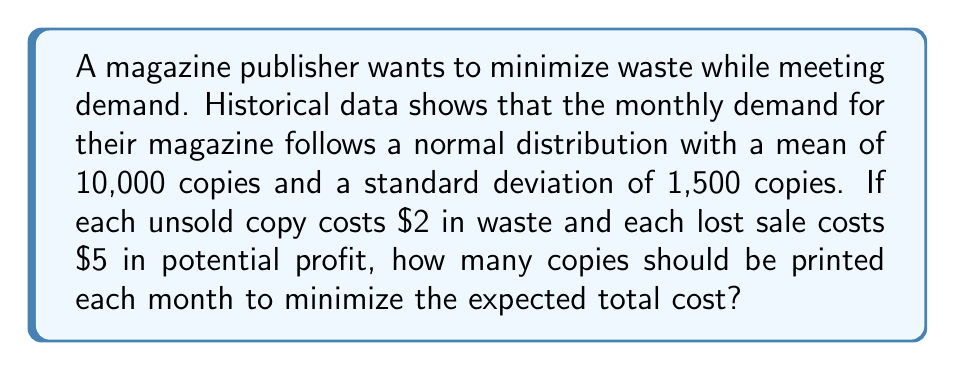Give your solution to this math problem. To solve this problem, we need to use the concept of the newsvendor model from inventory management theory. The optimal number of copies to print is the one that balances the cost of overprinting against the cost of underprinting.

Step 1: Calculate the critical fractile (CF)
CF = $\frac{c_u}{c_u + c_o}$
Where $c_u$ is the cost of underprinting (lost sale) and $c_o$ is the cost of overprinting (waste).

CF = $\frac{5}{5 + 2} = \frac{5}{7} \approx 0.7143$

Step 2: Find the z-score corresponding to the critical fractile
Using a standard normal distribution table or calculator, we find that the z-score for 0.7143 is approximately 0.5657.

Step 3: Calculate the optimal number of copies
Let $Q^*$ be the optimal number of copies, $\mu$ the mean demand, $\sigma$ the standard deviation, and $z$ the z-score.

$Q^* = \mu + z\sigma$

$Q^* = 10,000 + (0.5657 \times 1,500) = 10,000 + 848.55 = 10,848.55$

Step 4: Round to the nearest whole number
Since we can't print a fraction of a magazine, we round to the nearest integer.

$Q^* \approx 10,849$ copies
Answer: 10,849 copies 